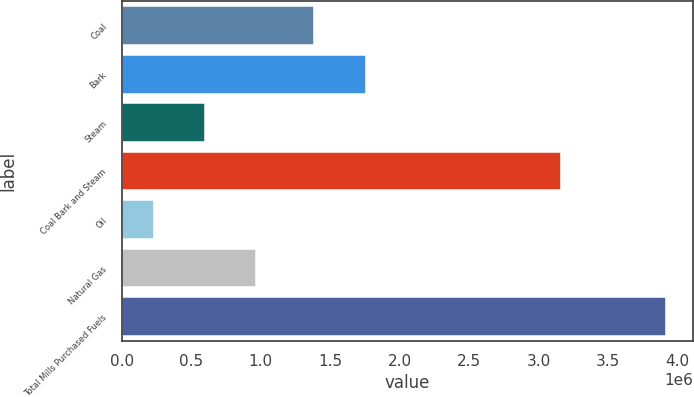Convert chart. <chart><loc_0><loc_0><loc_500><loc_500><bar_chart><fcel>Coal<fcel>Bark<fcel>Steam<fcel>Coal Bark and Steam<fcel>Oil<fcel>Natural Gas<fcel>Total Mills Purchased Fuels<nl><fcel>1.3854e+06<fcel>1.75395e+06<fcel>597246<fcel>3.16068e+06<fcel>228701<fcel>965790<fcel>3.91415e+06<nl></chart> 